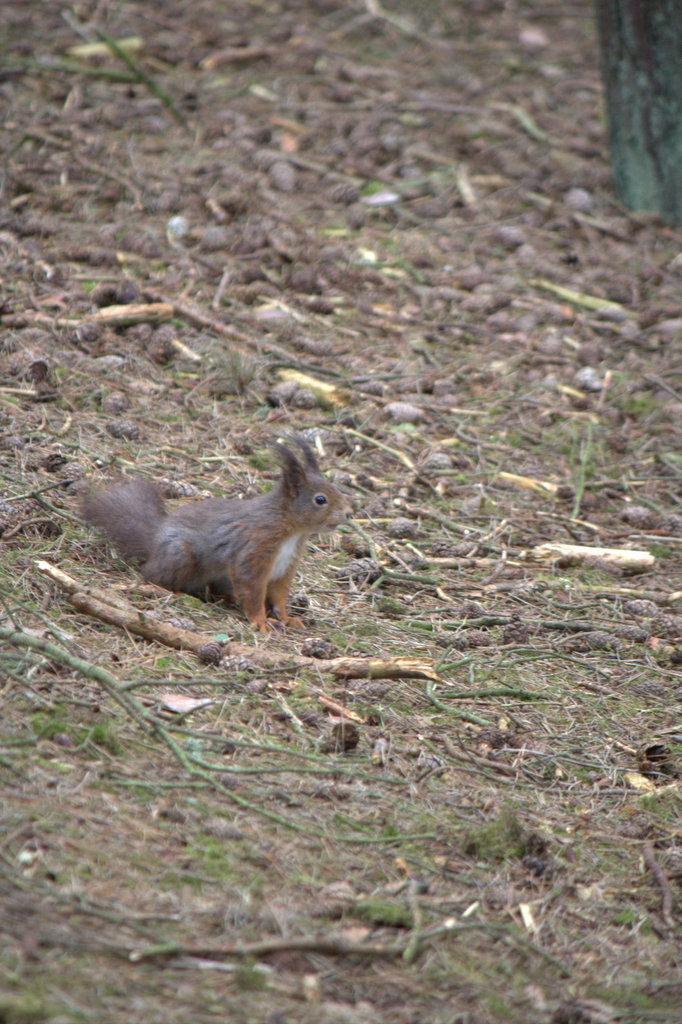Describe this image in one or two sentences. In the image there is a squirrel standing on land covered with twigs,grass and sand. 